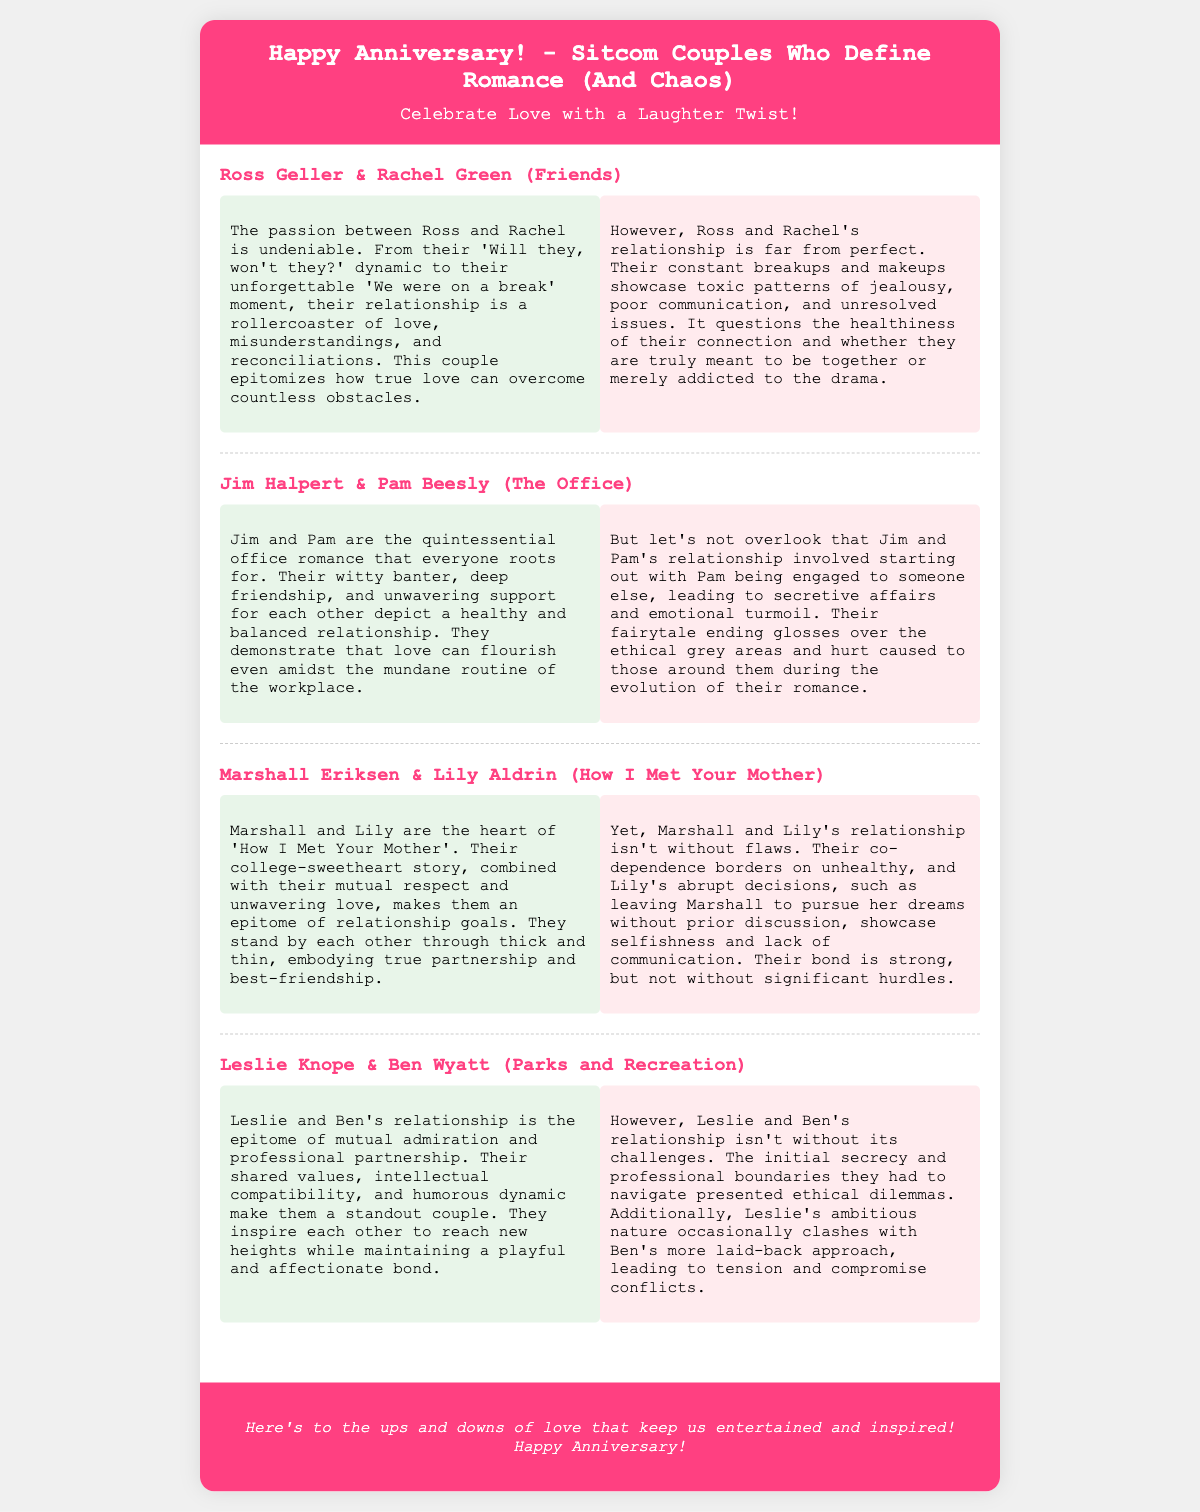What is the title of the card? The title of the card is presented prominently at the top and reads "Happy Anniversary! - Sitcom Couples Who Define Romance (And Chaos)".
Answer: Happy Anniversary! - Sitcom Couples Who Define Romance (And Chaos) Who are the first couple mentioned? The card lists Ross Geller and Rachel Green as the first couple in the content section.
Answer: Ross Geller & Rachel Green How many couples are discussed in total? The document features a total of four couples in its content section.
Answer: Four What color is the header background? The header background uses a bright color that is specified as #ff4081 in the document's CSS styling.
Answer: #ff4081 What type of dynamic is highlighted for Jim and Pam? The card describes Jim and Pam's relationship as an "office romance" that is very supportive.
Answer: Office romance In what way do Leslie and Ben's ambitions interact? The document discusses how Leslie's ambitious nature occasionally clashes with Ben's more laid-back approach.
Answer: Clashes What do Marshall and Lily's flaws predominantly relate to? The card suggests that Marshall and Lily's flaws involve their co-dependence and communication issues.
Answer: Co-dependence What is the footer's message about love? The footer emphasizes the ups and downs of love and their role in keeping us entertained and inspired.
Answer: Ups and downs of love 